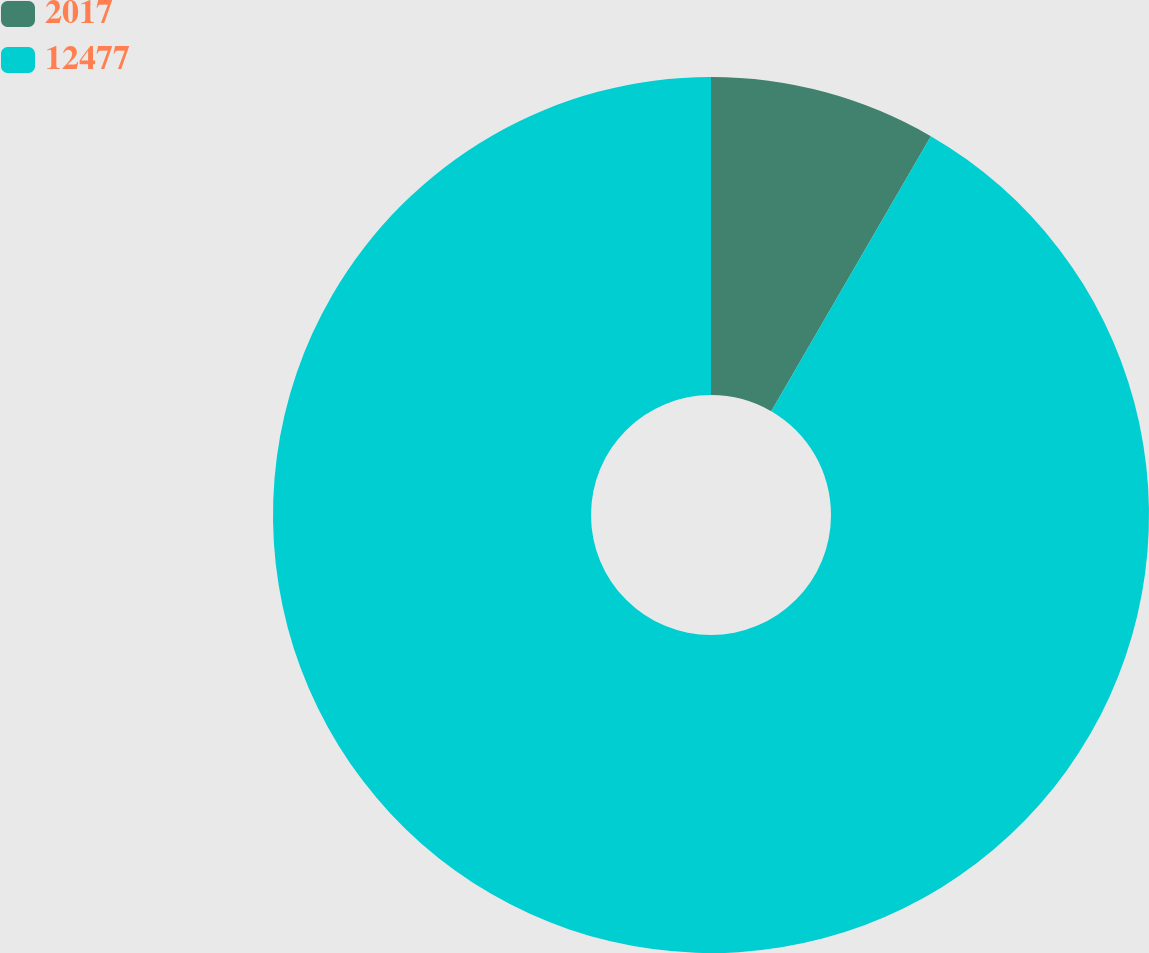Convert chart to OTSL. <chart><loc_0><loc_0><loc_500><loc_500><pie_chart><fcel>2017<fcel>12477<nl><fcel>8.37%<fcel>91.63%<nl></chart> 